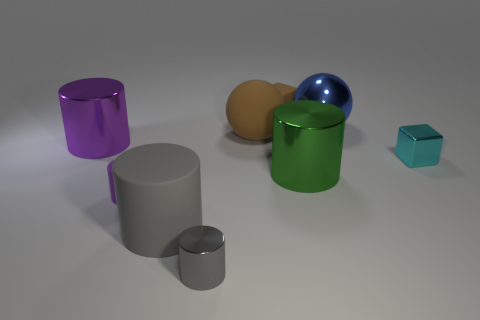Subtract all green cylinders. How many cylinders are left? 4 Subtract all small gray metallic cylinders. How many cylinders are left? 4 Subtract all blue cylinders. Subtract all brown spheres. How many cylinders are left? 5 Subtract all spheres. How many objects are left? 7 Add 7 gray metallic cylinders. How many gray metallic cylinders exist? 8 Subtract 1 green cylinders. How many objects are left? 8 Subtract all small yellow objects. Subtract all small matte cubes. How many objects are left? 8 Add 5 cyan shiny cubes. How many cyan shiny cubes are left? 6 